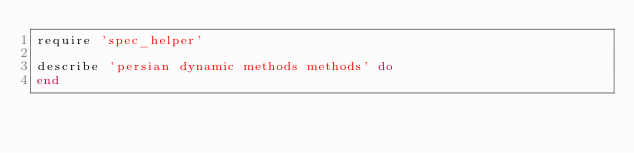Convert code to text. <code><loc_0><loc_0><loc_500><loc_500><_Ruby_>require 'spec_helper'

describe 'persian dynamic methods methods' do
end
</code> 